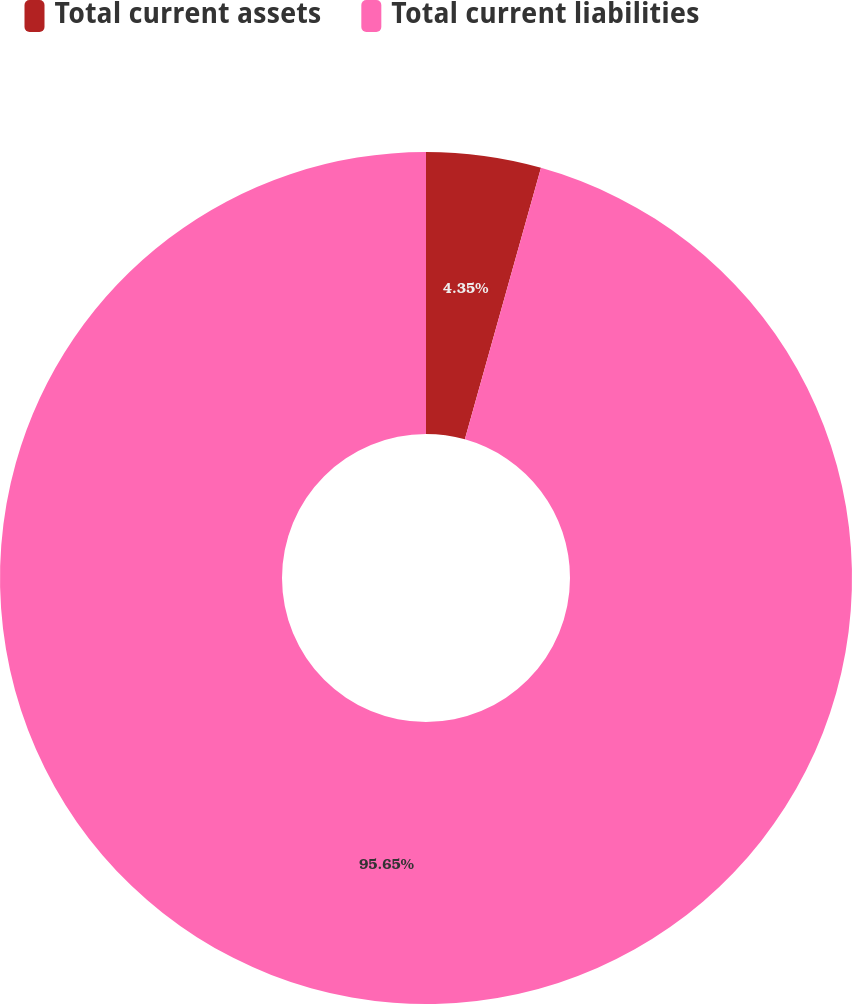Convert chart. <chart><loc_0><loc_0><loc_500><loc_500><pie_chart><fcel>Total current assets<fcel>Total current liabilities<nl><fcel>4.35%<fcel>95.65%<nl></chart> 